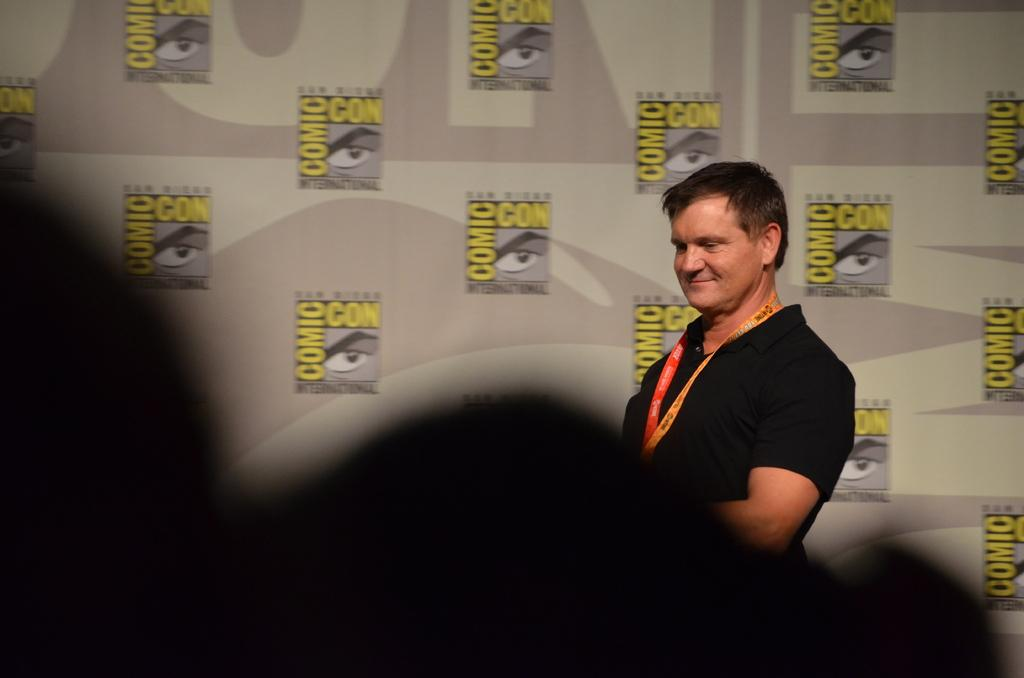Where was the image taken? The image was taken indoors. What can be seen in the background of the image? There is a banner with text in the background. Who is the main subject in the image? A man is standing in the middle of the image. What is the man's facial expression? The man has a smiling face. What type of meat is the man holding in the image? There is no meat present in the image; the man is not holding any food item. 